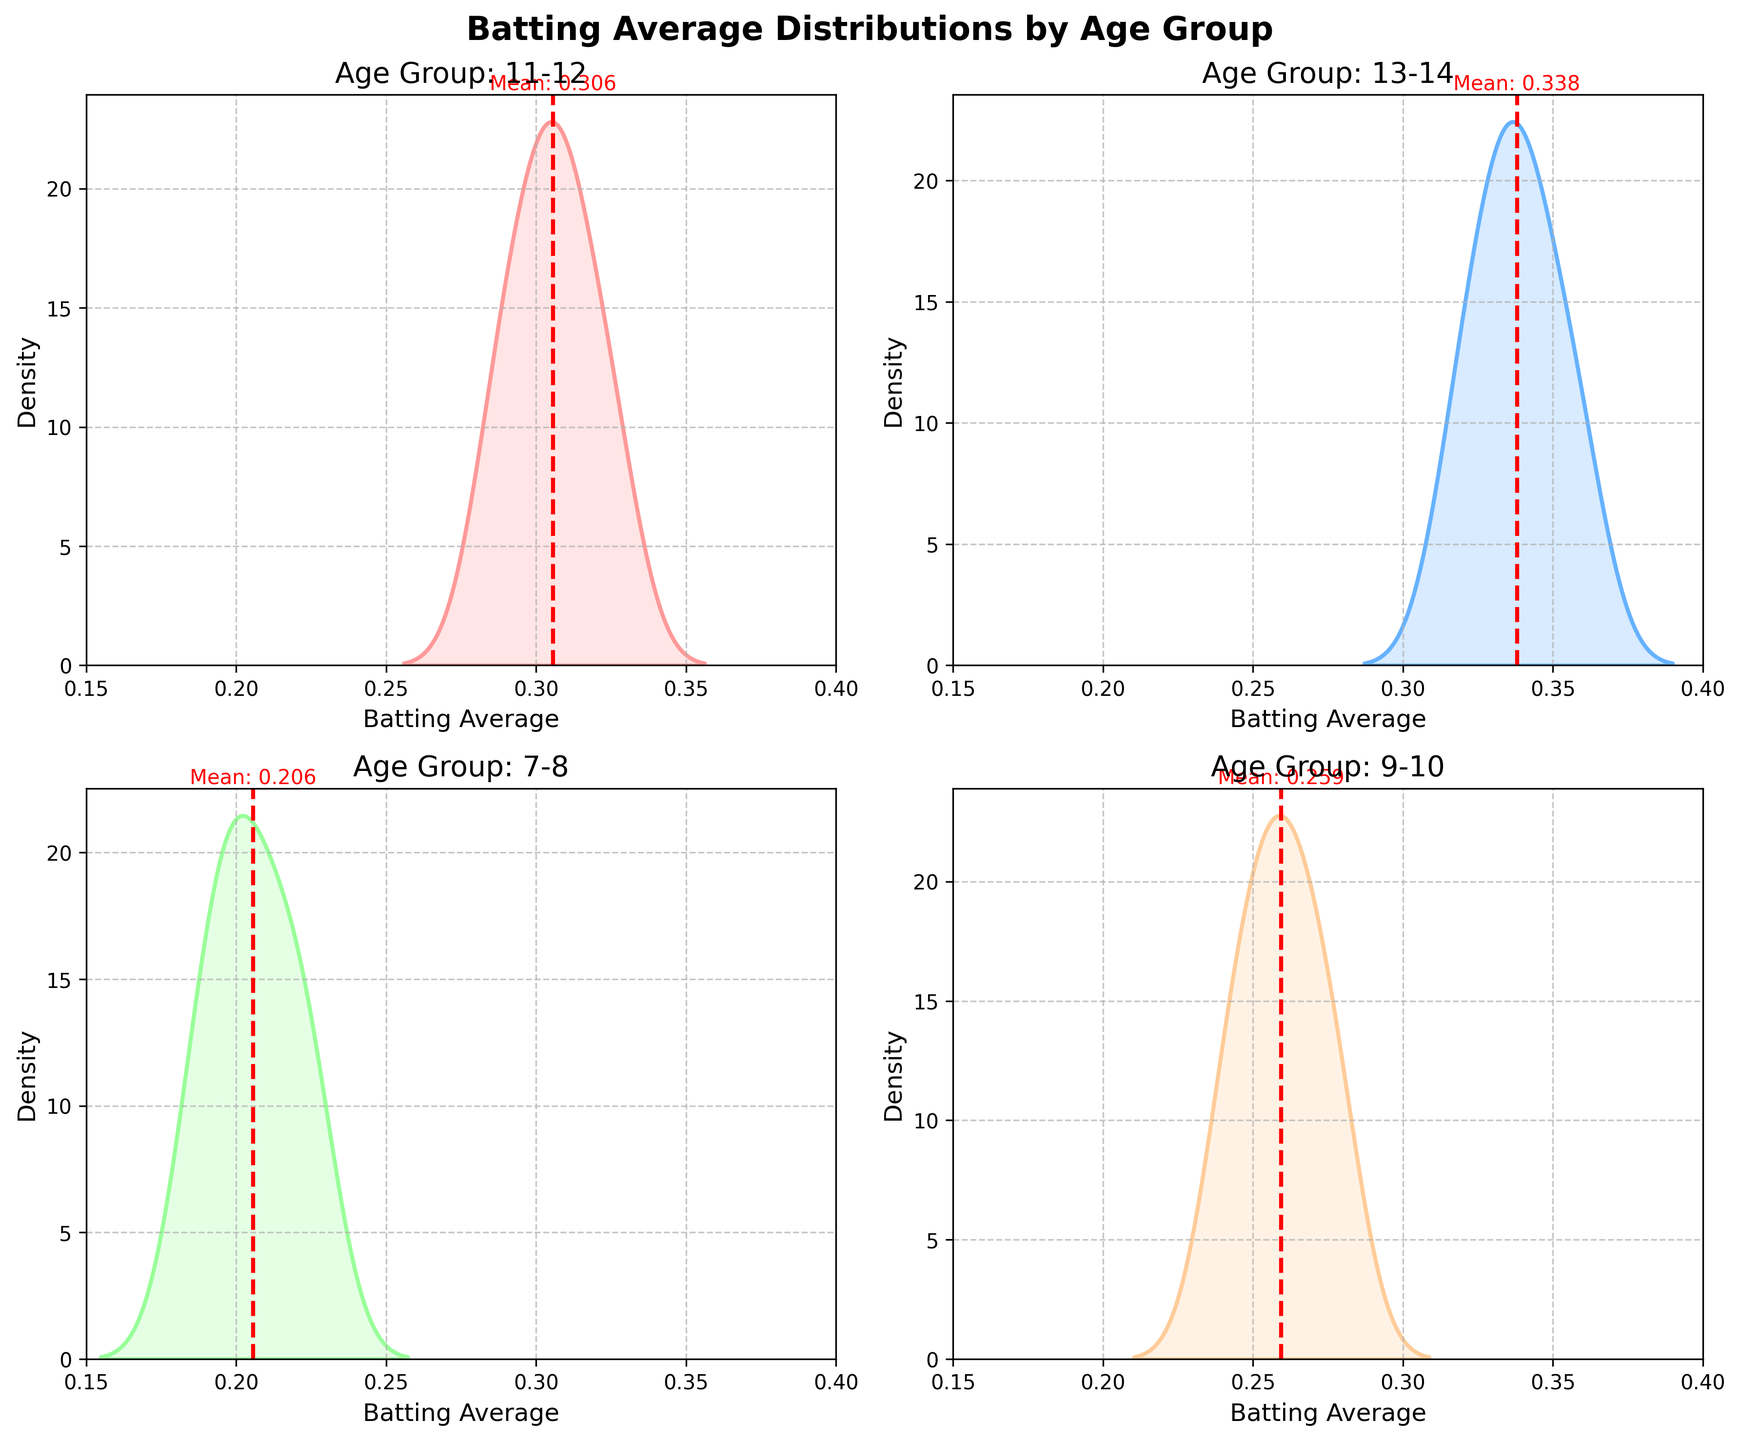How many subplot axes does the figure contain? The figure consists of four density plots, each representing one of the age groups (7-8, 9-10, 11-12, 13-14). The subplots are arranged in a 2 by 2 grid.
Answer: Four What is the title of the figure? The overall title at the top of the figure reads "Batting Average Distributions by Age Group" in bold text.
Answer: Batting Average Distributions by Age Group Which age group has the highest mean batting average? The subplot for the 13-14 age group shows a red dashed line that marks the mean of the distribution. It is positioned further to the right compared to the other age groups' mean lines.
Answer: 13-14 What is the range of the x-axis for each subplot? The x-axis on each density plot runs from 0.15 to 0.40, as defined in the figure configuration.
Answer: 0.15 to 0.40 Identify one age group where the density plot has a clear peak near the mean. The density plot for the 11-12 age group has a visibly distinct peak around its mean value, indicated by the red dashed line.
Answer: 11-12 Compare the dispersion of batting averages for age groups 7-8 and 13-14. The 7-8 age group's density plot is narrower, indicating less dispersion. The 13-14 age group's plot is broader but has a higher mean variability.
Answer: 7-8 has less dispersion Which age group has the lowest average batting average? The histogram for the 7-8 age group shows the mean line positioned closer to the left side of the x-axis compared to the other groups.
Answer: 7-8 What color is used to represent the 9-10 age group? The density plot for the 9-10 age group is shaded blue, as represented by the second color in the coded sequence.
Answer: Blue 